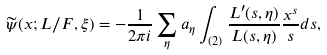Convert formula to latex. <formula><loc_0><loc_0><loc_500><loc_500>\widetilde { \psi } ( x ; L / F , \xi ) = - \frac { 1 } { 2 \pi i } \sum _ { \eta } a _ { \eta } \int _ { ( 2 ) } \frac { L ^ { \prime } ( s , \eta ) } { L ( s , \eta ) } \frac { x ^ { s } } { s } d s ,</formula> 